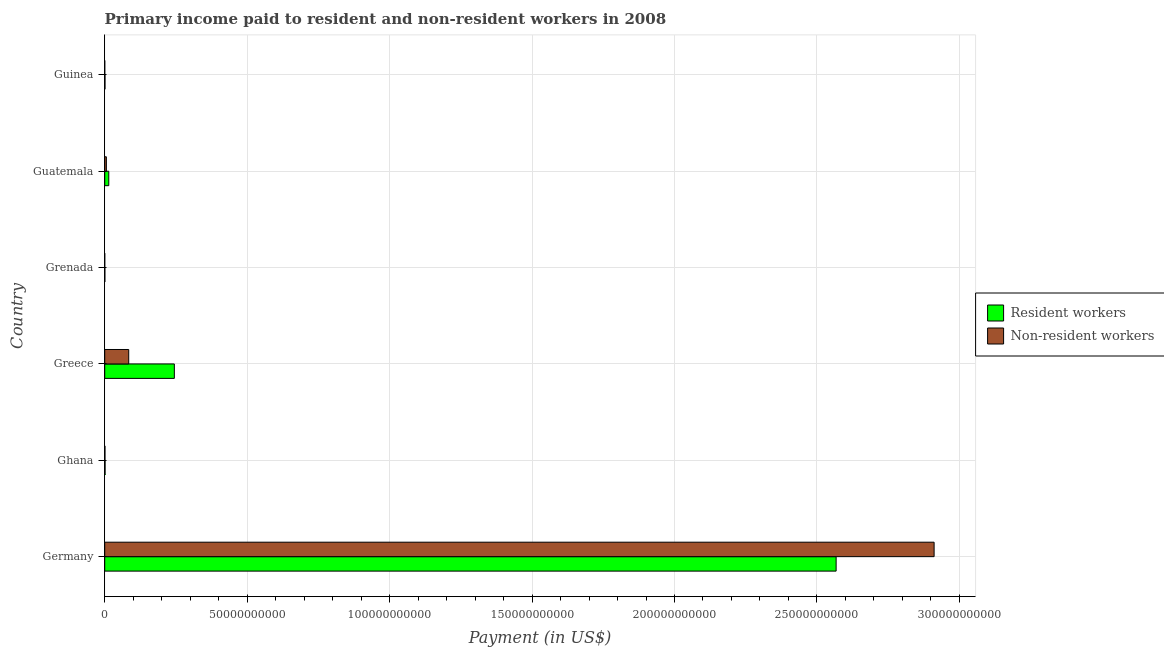How many groups of bars are there?
Your response must be concise. 6. How many bars are there on the 2nd tick from the bottom?
Provide a short and direct response. 2. What is the label of the 2nd group of bars from the top?
Your response must be concise. Guatemala. In how many cases, is the number of bars for a given country not equal to the number of legend labels?
Keep it short and to the point. 0. What is the payment made to resident workers in Grenada?
Your answer should be very brief. 5.08e+07. Across all countries, what is the maximum payment made to non-resident workers?
Keep it short and to the point. 2.91e+11. Across all countries, what is the minimum payment made to resident workers?
Your response must be concise. 5.08e+07. In which country was the payment made to non-resident workers maximum?
Your response must be concise. Germany. In which country was the payment made to non-resident workers minimum?
Your answer should be very brief. Grenada. What is the total payment made to resident workers in the graph?
Provide a succinct answer. 2.83e+11. What is the difference between the payment made to resident workers in Grenada and that in Guinea?
Ensure brevity in your answer.  -5.03e+07. What is the difference between the payment made to non-resident workers in Guatemala and the payment made to resident workers in Guinea?
Offer a very short reply. 4.82e+08. What is the average payment made to resident workers per country?
Keep it short and to the point. 4.71e+1. What is the difference between the payment made to non-resident workers and payment made to resident workers in Guatemala?
Your answer should be compact. -8.41e+08. In how many countries, is the payment made to resident workers greater than 160000000000 US$?
Provide a succinct answer. 1. What is the ratio of the payment made to resident workers in Germany to that in Ghana?
Provide a short and direct response. 1997.1. What is the difference between the highest and the second highest payment made to resident workers?
Your answer should be very brief. 2.32e+11. What is the difference between the highest and the lowest payment made to non-resident workers?
Give a very brief answer. 2.91e+11. Is the sum of the payment made to non-resident workers in Ghana and Guatemala greater than the maximum payment made to resident workers across all countries?
Your answer should be very brief. No. What does the 1st bar from the top in Germany represents?
Give a very brief answer. Non-resident workers. What does the 1st bar from the bottom in Germany represents?
Make the answer very short. Resident workers. How many bars are there?
Your response must be concise. 12. Are all the bars in the graph horizontal?
Keep it short and to the point. Yes. What is the difference between two consecutive major ticks on the X-axis?
Give a very brief answer. 5.00e+1. Are the values on the major ticks of X-axis written in scientific E-notation?
Offer a terse response. No. Does the graph contain grids?
Your answer should be compact. Yes. Where does the legend appear in the graph?
Your response must be concise. Center right. How many legend labels are there?
Offer a very short reply. 2. How are the legend labels stacked?
Provide a short and direct response. Vertical. What is the title of the graph?
Provide a short and direct response. Primary income paid to resident and non-resident workers in 2008. What is the label or title of the X-axis?
Your response must be concise. Payment (in US$). What is the Payment (in US$) in Resident workers in Germany?
Provide a succinct answer. 2.57e+11. What is the Payment (in US$) of Non-resident workers in Germany?
Offer a very short reply. 2.91e+11. What is the Payment (in US$) in Resident workers in Ghana?
Offer a very short reply. 1.29e+08. What is the Payment (in US$) in Non-resident workers in Ghana?
Ensure brevity in your answer.  8.56e+07. What is the Payment (in US$) in Resident workers in Greece?
Your response must be concise. 2.44e+1. What is the Payment (in US$) of Non-resident workers in Greece?
Keep it short and to the point. 8.43e+09. What is the Payment (in US$) of Resident workers in Grenada?
Offer a very short reply. 5.08e+07. What is the Payment (in US$) of Non-resident workers in Grenada?
Provide a short and direct response. 8.08e+06. What is the Payment (in US$) in Resident workers in Guatemala?
Your response must be concise. 1.42e+09. What is the Payment (in US$) in Non-resident workers in Guatemala?
Provide a succinct answer. 5.83e+08. What is the Payment (in US$) in Resident workers in Guinea?
Offer a very short reply. 1.01e+08. What is the Payment (in US$) in Non-resident workers in Guinea?
Provide a short and direct response. 9.85e+06. Across all countries, what is the maximum Payment (in US$) of Resident workers?
Offer a terse response. 2.57e+11. Across all countries, what is the maximum Payment (in US$) of Non-resident workers?
Your response must be concise. 2.91e+11. Across all countries, what is the minimum Payment (in US$) in Resident workers?
Ensure brevity in your answer.  5.08e+07. Across all countries, what is the minimum Payment (in US$) of Non-resident workers?
Your answer should be compact. 8.08e+06. What is the total Payment (in US$) of Resident workers in the graph?
Offer a very short reply. 2.83e+11. What is the total Payment (in US$) in Non-resident workers in the graph?
Your response must be concise. 3.00e+11. What is the difference between the Payment (in US$) of Resident workers in Germany and that in Ghana?
Make the answer very short. 2.57e+11. What is the difference between the Payment (in US$) in Non-resident workers in Germany and that in Ghana?
Give a very brief answer. 2.91e+11. What is the difference between the Payment (in US$) of Resident workers in Germany and that in Greece?
Offer a terse response. 2.32e+11. What is the difference between the Payment (in US$) of Non-resident workers in Germany and that in Greece?
Provide a short and direct response. 2.83e+11. What is the difference between the Payment (in US$) of Resident workers in Germany and that in Grenada?
Your response must be concise. 2.57e+11. What is the difference between the Payment (in US$) of Non-resident workers in Germany and that in Grenada?
Provide a short and direct response. 2.91e+11. What is the difference between the Payment (in US$) in Resident workers in Germany and that in Guatemala?
Your answer should be very brief. 2.55e+11. What is the difference between the Payment (in US$) in Non-resident workers in Germany and that in Guatemala?
Ensure brevity in your answer.  2.91e+11. What is the difference between the Payment (in US$) in Resident workers in Germany and that in Guinea?
Your response must be concise. 2.57e+11. What is the difference between the Payment (in US$) in Non-resident workers in Germany and that in Guinea?
Provide a succinct answer. 2.91e+11. What is the difference between the Payment (in US$) of Resident workers in Ghana and that in Greece?
Your answer should be compact. -2.43e+1. What is the difference between the Payment (in US$) in Non-resident workers in Ghana and that in Greece?
Make the answer very short. -8.34e+09. What is the difference between the Payment (in US$) in Resident workers in Ghana and that in Grenada?
Provide a succinct answer. 7.78e+07. What is the difference between the Payment (in US$) of Non-resident workers in Ghana and that in Grenada?
Your answer should be very brief. 7.75e+07. What is the difference between the Payment (in US$) of Resident workers in Ghana and that in Guatemala?
Provide a succinct answer. -1.30e+09. What is the difference between the Payment (in US$) in Non-resident workers in Ghana and that in Guatemala?
Your answer should be compact. -4.98e+08. What is the difference between the Payment (in US$) of Resident workers in Ghana and that in Guinea?
Make the answer very short. 2.75e+07. What is the difference between the Payment (in US$) of Non-resident workers in Ghana and that in Guinea?
Your answer should be compact. 7.57e+07. What is the difference between the Payment (in US$) in Resident workers in Greece and that in Grenada?
Your answer should be very brief. 2.44e+1. What is the difference between the Payment (in US$) of Non-resident workers in Greece and that in Grenada?
Offer a very short reply. 8.42e+09. What is the difference between the Payment (in US$) in Resident workers in Greece and that in Guatemala?
Your answer should be compact. 2.30e+1. What is the difference between the Payment (in US$) of Non-resident workers in Greece and that in Guatemala?
Your response must be concise. 7.84e+09. What is the difference between the Payment (in US$) of Resident workers in Greece and that in Guinea?
Make the answer very short. 2.43e+1. What is the difference between the Payment (in US$) in Non-resident workers in Greece and that in Guinea?
Give a very brief answer. 8.42e+09. What is the difference between the Payment (in US$) of Resident workers in Grenada and that in Guatemala?
Your response must be concise. -1.37e+09. What is the difference between the Payment (in US$) of Non-resident workers in Grenada and that in Guatemala?
Give a very brief answer. -5.75e+08. What is the difference between the Payment (in US$) in Resident workers in Grenada and that in Guinea?
Provide a short and direct response. -5.03e+07. What is the difference between the Payment (in US$) of Non-resident workers in Grenada and that in Guinea?
Keep it short and to the point. -1.77e+06. What is the difference between the Payment (in US$) of Resident workers in Guatemala and that in Guinea?
Make the answer very short. 1.32e+09. What is the difference between the Payment (in US$) of Non-resident workers in Guatemala and that in Guinea?
Offer a very short reply. 5.73e+08. What is the difference between the Payment (in US$) of Resident workers in Germany and the Payment (in US$) of Non-resident workers in Ghana?
Make the answer very short. 2.57e+11. What is the difference between the Payment (in US$) of Resident workers in Germany and the Payment (in US$) of Non-resident workers in Greece?
Keep it short and to the point. 2.48e+11. What is the difference between the Payment (in US$) of Resident workers in Germany and the Payment (in US$) of Non-resident workers in Grenada?
Give a very brief answer. 2.57e+11. What is the difference between the Payment (in US$) of Resident workers in Germany and the Payment (in US$) of Non-resident workers in Guatemala?
Make the answer very short. 2.56e+11. What is the difference between the Payment (in US$) of Resident workers in Germany and the Payment (in US$) of Non-resident workers in Guinea?
Your answer should be very brief. 2.57e+11. What is the difference between the Payment (in US$) of Resident workers in Ghana and the Payment (in US$) of Non-resident workers in Greece?
Provide a short and direct response. -8.30e+09. What is the difference between the Payment (in US$) in Resident workers in Ghana and the Payment (in US$) in Non-resident workers in Grenada?
Offer a terse response. 1.20e+08. What is the difference between the Payment (in US$) of Resident workers in Ghana and the Payment (in US$) of Non-resident workers in Guatemala?
Offer a very short reply. -4.55e+08. What is the difference between the Payment (in US$) of Resident workers in Ghana and the Payment (in US$) of Non-resident workers in Guinea?
Give a very brief answer. 1.19e+08. What is the difference between the Payment (in US$) in Resident workers in Greece and the Payment (in US$) in Non-resident workers in Grenada?
Offer a very short reply. 2.44e+1. What is the difference between the Payment (in US$) in Resident workers in Greece and the Payment (in US$) in Non-resident workers in Guatemala?
Provide a short and direct response. 2.39e+1. What is the difference between the Payment (in US$) in Resident workers in Greece and the Payment (in US$) in Non-resident workers in Guinea?
Your answer should be very brief. 2.44e+1. What is the difference between the Payment (in US$) of Resident workers in Grenada and the Payment (in US$) of Non-resident workers in Guatemala?
Your answer should be very brief. -5.32e+08. What is the difference between the Payment (in US$) of Resident workers in Grenada and the Payment (in US$) of Non-resident workers in Guinea?
Your answer should be very brief. 4.09e+07. What is the difference between the Payment (in US$) of Resident workers in Guatemala and the Payment (in US$) of Non-resident workers in Guinea?
Make the answer very short. 1.41e+09. What is the average Payment (in US$) in Resident workers per country?
Keep it short and to the point. 4.71e+1. What is the average Payment (in US$) in Non-resident workers per country?
Offer a very short reply. 5.00e+1. What is the difference between the Payment (in US$) in Resident workers and Payment (in US$) in Non-resident workers in Germany?
Give a very brief answer. -3.44e+1. What is the difference between the Payment (in US$) of Resident workers and Payment (in US$) of Non-resident workers in Ghana?
Your answer should be compact. 4.30e+07. What is the difference between the Payment (in US$) in Resident workers and Payment (in US$) in Non-resident workers in Greece?
Your answer should be very brief. 1.60e+1. What is the difference between the Payment (in US$) of Resident workers and Payment (in US$) of Non-resident workers in Grenada?
Offer a very short reply. 4.27e+07. What is the difference between the Payment (in US$) in Resident workers and Payment (in US$) in Non-resident workers in Guatemala?
Make the answer very short. 8.41e+08. What is the difference between the Payment (in US$) in Resident workers and Payment (in US$) in Non-resident workers in Guinea?
Your answer should be very brief. 9.12e+07. What is the ratio of the Payment (in US$) of Resident workers in Germany to that in Ghana?
Keep it short and to the point. 1997.09. What is the ratio of the Payment (in US$) of Non-resident workers in Germany to that in Ghana?
Provide a succinct answer. 3402.5. What is the ratio of the Payment (in US$) of Resident workers in Germany to that in Greece?
Keep it short and to the point. 10.5. What is the ratio of the Payment (in US$) in Non-resident workers in Germany to that in Greece?
Provide a short and direct response. 34.55. What is the ratio of the Payment (in US$) in Resident workers in Germany to that in Grenada?
Your response must be concise. 5054.47. What is the ratio of the Payment (in US$) of Non-resident workers in Germany to that in Grenada?
Offer a very short reply. 3.60e+04. What is the ratio of the Payment (in US$) in Resident workers in Germany to that in Guatemala?
Offer a very short reply. 180.32. What is the ratio of the Payment (in US$) in Non-resident workers in Germany to that in Guatemala?
Your answer should be compact. 499.13. What is the ratio of the Payment (in US$) in Resident workers in Germany to that in Guinea?
Provide a short and direct response. 2540.7. What is the ratio of the Payment (in US$) of Non-resident workers in Germany to that in Guinea?
Your answer should be very brief. 2.96e+04. What is the ratio of the Payment (in US$) of Resident workers in Ghana to that in Greece?
Provide a short and direct response. 0.01. What is the ratio of the Payment (in US$) of Non-resident workers in Ghana to that in Greece?
Your answer should be compact. 0.01. What is the ratio of the Payment (in US$) in Resident workers in Ghana to that in Grenada?
Provide a succinct answer. 2.53. What is the ratio of the Payment (in US$) of Non-resident workers in Ghana to that in Grenada?
Offer a terse response. 10.59. What is the ratio of the Payment (in US$) in Resident workers in Ghana to that in Guatemala?
Ensure brevity in your answer.  0.09. What is the ratio of the Payment (in US$) of Non-resident workers in Ghana to that in Guatemala?
Provide a succinct answer. 0.15. What is the ratio of the Payment (in US$) in Resident workers in Ghana to that in Guinea?
Ensure brevity in your answer.  1.27. What is the ratio of the Payment (in US$) in Non-resident workers in Ghana to that in Guinea?
Offer a terse response. 8.69. What is the ratio of the Payment (in US$) in Resident workers in Greece to that in Grenada?
Provide a succinct answer. 481.2. What is the ratio of the Payment (in US$) in Non-resident workers in Greece to that in Grenada?
Offer a terse response. 1042.62. What is the ratio of the Payment (in US$) of Resident workers in Greece to that in Guatemala?
Ensure brevity in your answer.  17.17. What is the ratio of the Payment (in US$) of Non-resident workers in Greece to that in Guatemala?
Offer a terse response. 14.45. What is the ratio of the Payment (in US$) in Resident workers in Greece to that in Guinea?
Offer a terse response. 241.88. What is the ratio of the Payment (in US$) of Non-resident workers in Greece to that in Guinea?
Ensure brevity in your answer.  855.53. What is the ratio of the Payment (in US$) in Resident workers in Grenada to that in Guatemala?
Keep it short and to the point. 0.04. What is the ratio of the Payment (in US$) in Non-resident workers in Grenada to that in Guatemala?
Provide a succinct answer. 0.01. What is the ratio of the Payment (in US$) of Resident workers in Grenada to that in Guinea?
Your response must be concise. 0.5. What is the ratio of the Payment (in US$) of Non-resident workers in Grenada to that in Guinea?
Your answer should be very brief. 0.82. What is the ratio of the Payment (in US$) in Resident workers in Guatemala to that in Guinea?
Ensure brevity in your answer.  14.09. What is the ratio of the Payment (in US$) of Non-resident workers in Guatemala to that in Guinea?
Provide a short and direct response. 59.22. What is the difference between the highest and the second highest Payment (in US$) of Resident workers?
Keep it short and to the point. 2.32e+11. What is the difference between the highest and the second highest Payment (in US$) in Non-resident workers?
Provide a succinct answer. 2.83e+11. What is the difference between the highest and the lowest Payment (in US$) in Resident workers?
Give a very brief answer. 2.57e+11. What is the difference between the highest and the lowest Payment (in US$) in Non-resident workers?
Your answer should be very brief. 2.91e+11. 